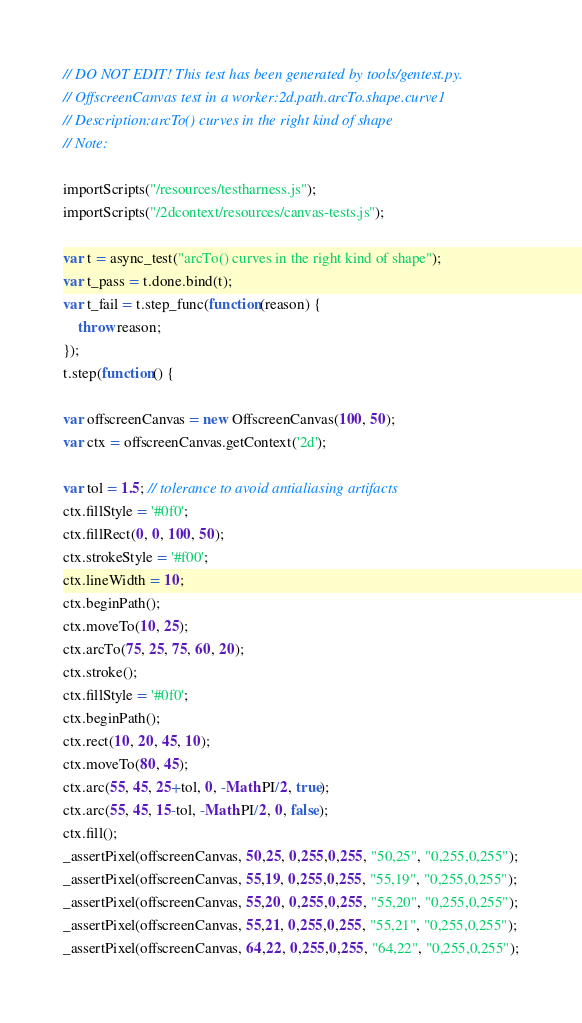<code> <loc_0><loc_0><loc_500><loc_500><_JavaScript_>// DO NOT EDIT! This test has been generated by tools/gentest.py.
// OffscreenCanvas test in a worker:2d.path.arcTo.shape.curve1
// Description:arcTo() curves in the right kind of shape
// Note:

importScripts("/resources/testharness.js");
importScripts("/2dcontext/resources/canvas-tests.js");

var t = async_test("arcTo() curves in the right kind of shape");
var t_pass = t.done.bind(t);
var t_fail = t.step_func(function(reason) {
    throw reason;
});
t.step(function() {

var offscreenCanvas = new OffscreenCanvas(100, 50);
var ctx = offscreenCanvas.getContext('2d');

var tol = 1.5; // tolerance to avoid antialiasing artifacts
ctx.fillStyle = '#0f0';
ctx.fillRect(0, 0, 100, 50);
ctx.strokeStyle = '#f00';
ctx.lineWidth = 10;
ctx.beginPath();
ctx.moveTo(10, 25);
ctx.arcTo(75, 25, 75, 60, 20);
ctx.stroke();
ctx.fillStyle = '#0f0';
ctx.beginPath();
ctx.rect(10, 20, 45, 10);
ctx.moveTo(80, 45);
ctx.arc(55, 45, 25+tol, 0, -Math.PI/2, true);
ctx.arc(55, 45, 15-tol, -Math.PI/2, 0, false);
ctx.fill();
_assertPixel(offscreenCanvas, 50,25, 0,255,0,255, "50,25", "0,255,0,255");
_assertPixel(offscreenCanvas, 55,19, 0,255,0,255, "55,19", "0,255,0,255");
_assertPixel(offscreenCanvas, 55,20, 0,255,0,255, "55,20", "0,255,0,255");
_assertPixel(offscreenCanvas, 55,21, 0,255,0,255, "55,21", "0,255,0,255");
_assertPixel(offscreenCanvas, 64,22, 0,255,0,255, "64,22", "0,255,0,255");</code> 